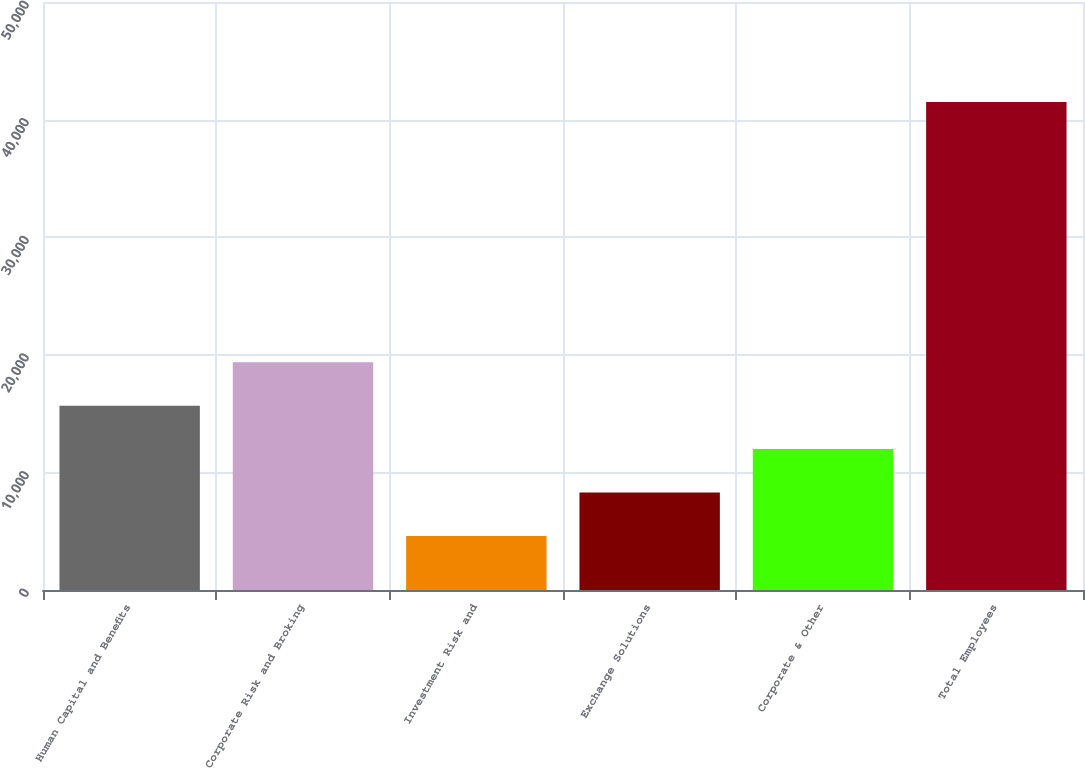Convert chart to OTSL. <chart><loc_0><loc_0><loc_500><loc_500><bar_chart><fcel>Human Capital and Benefits<fcel>Corporate Risk and Broking<fcel>Investment Risk and<fcel>Exchange Solutions<fcel>Corporate & Other<fcel>Total Employees<nl><fcel>15670<fcel>19360<fcel>4600<fcel>8290<fcel>11980<fcel>41500<nl></chart> 